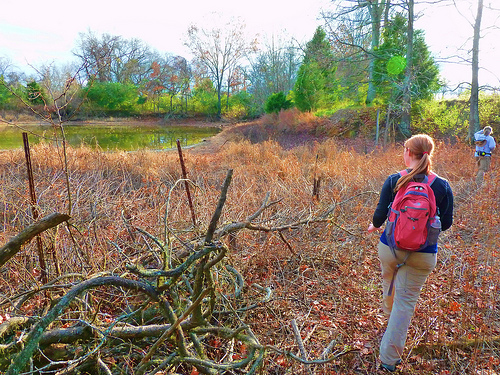<image>
Is there a swamp above the branches? No. The swamp is not positioned above the branches. The vertical arrangement shows a different relationship. 